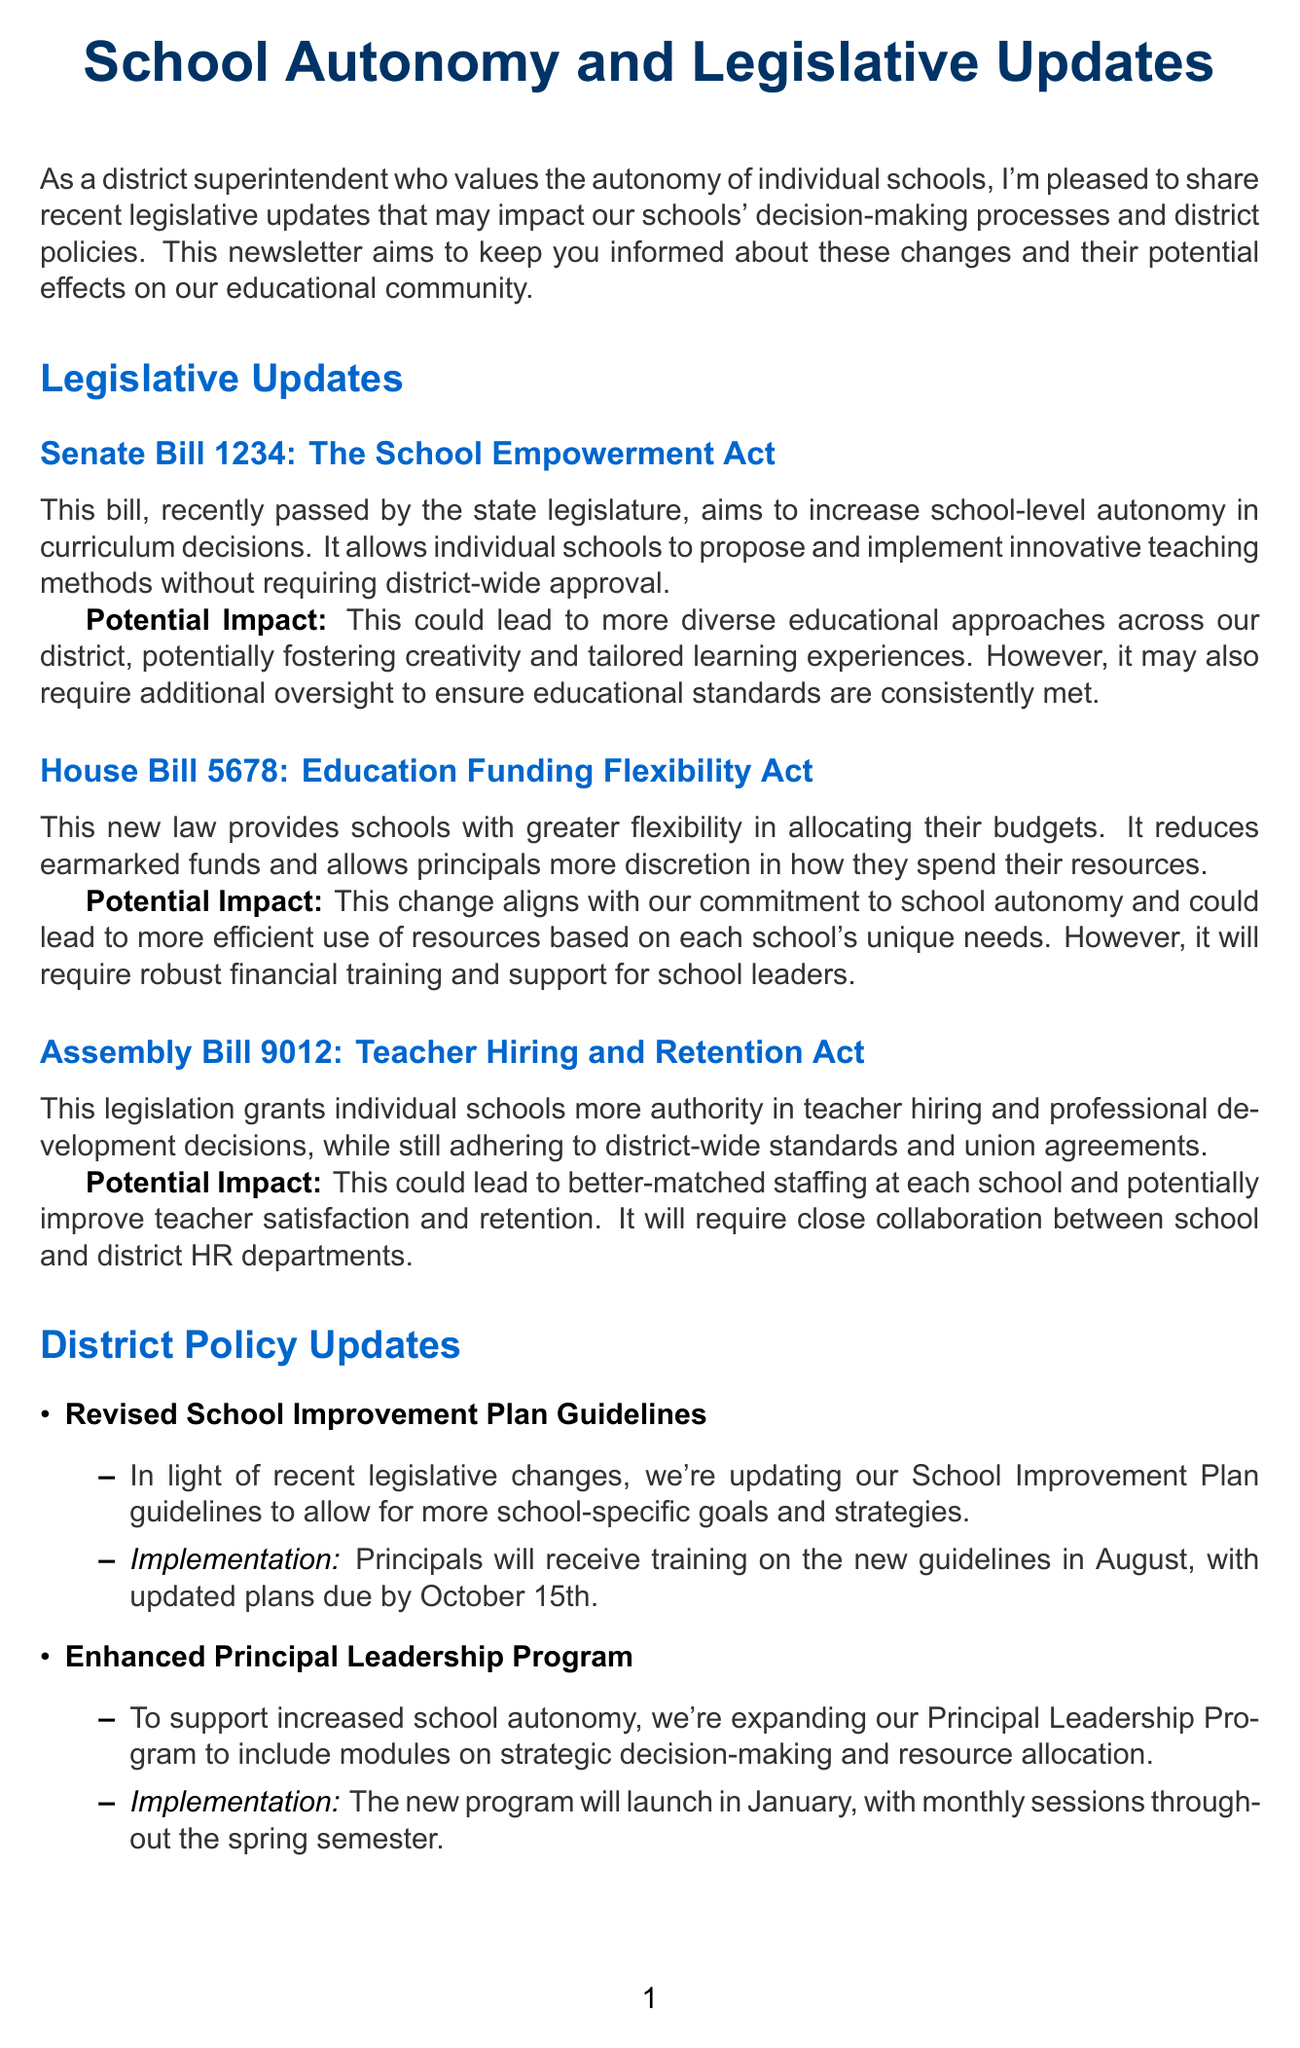What is the title of the newsletter? The title of the newsletter is explicitly stated at the beginning of the document.
Answer: School Autonomy and Legislative Updates What is Senate Bill 1234 also known as? The document provides specific titles for each legislative update and their nicknames.
Answer: The School Empowerment Act When is the School Autonomy Workshop scheduled? The date is mentioned in the upcoming events section of the document.
Answer: September 15, 2023 What aspect of school operations does House Bill 5678 address? The description indicates the focus of the bill, which is highlighted in the legislative updates section.
Answer: Education funding flexibility What is the implementation date for the Revised School Improvement Plan Guidelines? This information is found in the district policy updates section, detailing timelines for updates.
Answer: October 15th Who provided expert analysis on the legislative changes? The document mentions the analyst's name and professional affiliation in the expert analysis section.
Answer: Dr. Emily Rodriguez What is a potential impact of Assembly Bill 9012? The potential impact is outlined in the description of the legislative update.
Answer: Improve teacher satisfaction and retention What will the Enhanced Principal Leadership Program include? The description in the district policy updates section outlines the contents of the program.
Answer: Modules on strategic decision-making and resource allocation 